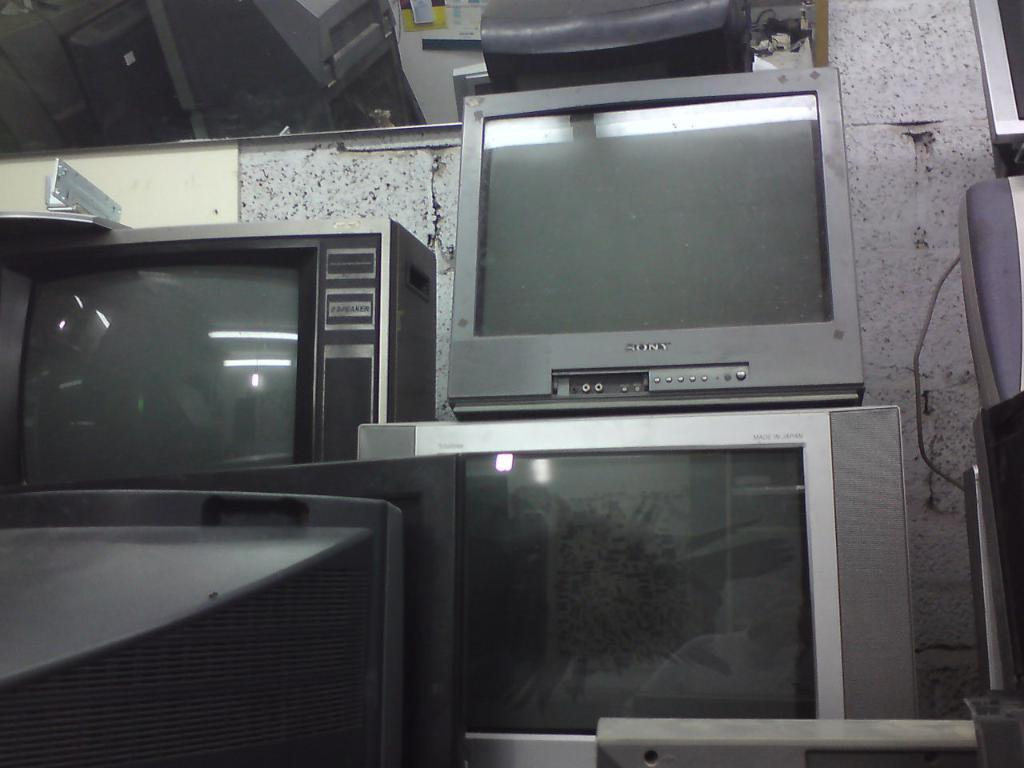<image>
Create a compact narrative representing the image presented. Many old televisions, one of which is Sony branded, are stacked on top of each other. 